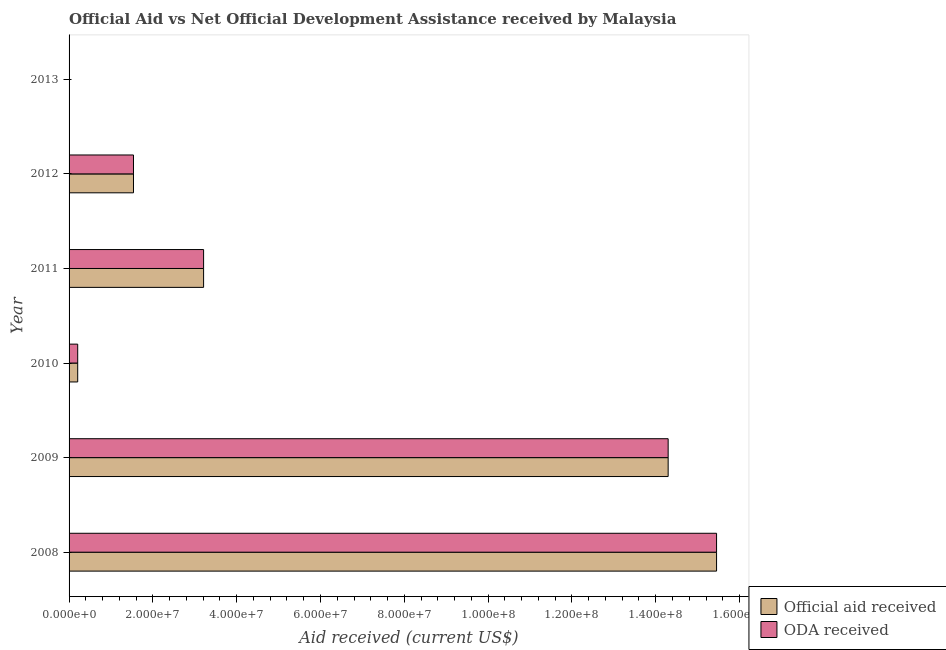Are the number of bars per tick equal to the number of legend labels?
Give a very brief answer. No. Are the number of bars on each tick of the Y-axis equal?
Give a very brief answer. No. How many bars are there on the 6th tick from the bottom?
Provide a short and direct response. 0. What is the label of the 6th group of bars from the top?
Keep it short and to the point. 2008. What is the official aid received in 2009?
Provide a short and direct response. 1.43e+08. Across all years, what is the maximum oda received?
Provide a short and direct response. 1.55e+08. What is the total oda received in the graph?
Keep it short and to the point. 3.47e+08. What is the difference between the oda received in 2008 and that in 2012?
Your answer should be very brief. 1.39e+08. What is the difference between the oda received in 2009 and the official aid received in 2011?
Your answer should be very brief. 1.11e+08. What is the average oda received per year?
Provide a short and direct response. 5.78e+07. In how many years, is the official aid received greater than 12000000 US$?
Give a very brief answer. 4. What is the ratio of the oda received in 2008 to that in 2012?
Give a very brief answer. 10.05. Is the official aid received in 2008 less than that in 2011?
Give a very brief answer. No. What is the difference between the highest and the second highest oda received?
Make the answer very short. 1.16e+07. What is the difference between the highest and the lowest official aid received?
Offer a terse response. 1.55e+08. Is the sum of the official aid received in 2011 and 2012 greater than the maximum oda received across all years?
Keep it short and to the point. No. How many bars are there?
Your response must be concise. 10. Does the graph contain grids?
Keep it short and to the point. No. How many legend labels are there?
Give a very brief answer. 2. What is the title of the graph?
Offer a very short reply. Official Aid vs Net Official Development Assistance received by Malaysia . Does "Urban" appear as one of the legend labels in the graph?
Offer a very short reply. No. What is the label or title of the X-axis?
Your answer should be compact. Aid received (current US$). What is the Aid received (current US$) of Official aid received in 2008?
Give a very brief answer. 1.55e+08. What is the Aid received (current US$) of ODA received in 2008?
Make the answer very short. 1.55e+08. What is the Aid received (current US$) of Official aid received in 2009?
Ensure brevity in your answer.  1.43e+08. What is the Aid received (current US$) of ODA received in 2009?
Your response must be concise. 1.43e+08. What is the Aid received (current US$) of Official aid received in 2010?
Your answer should be compact. 2.06e+06. What is the Aid received (current US$) of ODA received in 2010?
Offer a terse response. 2.06e+06. What is the Aid received (current US$) of Official aid received in 2011?
Offer a terse response. 3.21e+07. What is the Aid received (current US$) in ODA received in 2011?
Your answer should be compact. 3.21e+07. What is the Aid received (current US$) of Official aid received in 2012?
Your answer should be very brief. 1.54e+07. What is the Aid received (current US$) in ODA received in 2012?
Offer a terse response. 1.54e+07. Across all years, what is the maximum Aid received (current US$) in Official aid received?
Offer a terse response. 1.55e+08. Across all years, what is the maximum Aid received (current US$) in ODA received?
Offer a very short reply. 1.55e+08. Across all years, what is the minimum Aid received (current US$) in Official aid received?
Keep it short and to the point. 0. Across all years, what is the minimum Aid received (current US$) in ODA received?
Provide a succinct answer. 0. What is the total Aid received (current US$) in Official aid received in the graph?
Make the answer very short. 3.47e+08. What is the total Aid received (current US$) in ODA received in the graph?
Your answer should be compact. 3.47e+08. What is the difference between the Aid received (current US$) of Official aid received in 2008 and that in 2009?
Give a very brief answer. 1.16e+07. What is the difference between the Aid received (current US$) of ODA received in 2008 and that in 2009?
Your answer should be compact. 1.16e+07. What is the difference between the Aid received (current US$) in Official aid received in 2008 and that in 2010?
Give a very brief answer. 1.52e+08. What is the difference between the Aid received (current US$) of ODA received in 2008 and that in 2010?
Give a very brief answer. 1.52e+08. What is the difference between the Aid received (current US$) in Official aid received in 2008 and that in 2011?
Your response must be concise. 1.22e+08. What is the difference between the Aid received (current US$) in ODA received in 2008 and that in 2011?
Provide a succinct answer. 1.22e+08. What is the difference between the Aid received (current US$) of Official aid received in 2008 and that in 2012?
Ensure brevity in your answer.  1.39e+08. What is the difference between the Aid received (current US$) of ODA received in 2008 and that in 2012?
Offer a very short reply. 1.39e+08. What is the difference between the Aid received (current US$) in Official aid received in 2009 and that in 2010?
Your response must be concise. 1.41e+08. What is the difference between the Aid received (current US$) of ODA received in 2009 and that in 2010?
Provide a short and direct response. 1.41e+08. What is the difference between the Aid received (current US$) of Official aid received in 2009 and that in 2011?
Keep it short and to the point. 1.11e+08. What is the difference between the Aid received (current US$) in ODA received in 2009 and that in 2011?
Your answer should be very brief. 1.11e+08. What is the difference between the Aid received (current US$) of Official aid received in 2009 and that in 2012?
Provide a succinct answer. 1.28e+08. What is the difference between the Aid received (current US$) in ODA received in 2009 and that in 2012?
Offer a terse response. 1.28e+08. What is the difference between the Aid received (current US$) in Official aid received in 2010 and that in 2011?
Give a very brief answer. -3.00e+07. What is the difference between the Aid received (current US$) of ODA received in 2010 and that in 2011?
Provide a succinct answer. -3.00e+07. What is the difference between the Aid received (current US$) of Official aid received in 2010 and that in 2012?
Offer a terse response. -1.33e+07. What is the difference between the Aid received (current US$) in ODA received in 2010 and that in 2012?
Your response must be concise. -1.33e+07. What is the difference between the Aid received (current US$) of Official aid received in 2011 and that in 2012?
Your answer should be very brief. 1.67e+07. What is the difference between the Aid received (current US$) of ODA received in 2011 and that in 2012?
Give a very brief answer. 1.67e+07. What is the difference between the Aid received (current US$) in Official aid received in 2008 and the Aid received (current US$) in ODA received in 2009?
Offer a terse response. 1.16e+07. What is the difference between the Aid received (current US$) in Official aid received in 2008 and the Aid received (current US$) in ODA received in 2010?
Your answer should be very brief. 1.52e+08. What is the difference between the Aid received (current US$) of Official aid received in 2008 and the Aid received (current US$) of ODA received in 2011?
Provide a short and direct response. 1.22e+08. What is the difference between the Aid received (current US$) of Official aid received in 2008 and the Aid received (current US$) of ODA received in 2012?
Provide a succinct answer. 1.39e+08. What is the difference between the Aid received (current US$) of Official aid received in 2009 and the Aid received (current US$) of ODA received in 2010?
Make the answer very short. 1.41e+08. What is the difference between the Aid received (current US$) of Official aid received in 2009 and the Aid received (current US$) of ODA received in 2011?
Ensure brevity in your answer.  1.11e+08. What is the difference between the Aid received (current US$) of Official aid received in 2009 and the Aid received (current US$) of ODA received in 2012?
Provide a succinct answer. 1.28e+08. What is the difference between the Aid received (current US$) of Official aid received in 2010 and the Aid received (current US$) of ODA received in 2011?
Make the answer very short. -3.00e+07. What is the difference between the Aid received (current US$) in Official aid received in 2010 and the Aid received (current US$) in ODA received in 2012?
Make the answer very short. -1.33e+07. What is the difference between the Aid received (current US$) in Official aid received in 2011 and the Aid received (current US$) in ODA received in 2012?
Your answer should be very brief. 1.67e+07. What is the average Aid received (current US$) in Official aid received per year?
Keep it short and to the point. 5.78e+07. What is the average Aid received (current US$) in ODA received per year?
Make the answer very short. 5.78e+07. In the year 2008, what is the difference between the Aid received (current US$) in Official aid received and Aid received (current US$) in ODA received?
Offer a very short reply. 0. In the year 2009, what is the difference between the Aid received (current US$) of Official aid received and Aid received (current US$) of ODA received?
Give a very brief answer. 0. In the year 2010, what is the difference between the Aid received (current US$) in Official aid received and Aid received (current US$) in ODA received?
Your answer should be very brief. 0. In the year 2011, what is the difference between the Aid received (current US$) in Official aid received and Aid received (current US$) in ODA received?
Offer a terse response. 0. In the year 2012, what is the difference between the Aid received (current US$) in Official aid received and Aid received (current US$) in ODA received?
Your response must be concise. 0. What is the ratio of the Aid received (current US$) in Official aid received in 2008 to that in 2009?
Ensure brevity in your answer.  1.08. What is the ratio of the Aid received (current US$) in ODA received in 2008 to that in 2009?
Keep it short and to the point. 1.08. What is the ratio of the Aid received (current US$) in Official aid received in 2008 to that in 2010?
Keep it short and to the point. 75. What is the ratio of the Aid received (current US$) in ODA received in 2008 to that in 2010?
Keep it short and to the point. 75. What is the ratio of the Aid received (current US$) in Official aid received in 2008 to that in 2011?
Offer a terse response. 4.81. What is the ratio of the Aid received (current US$) of ODA received in 2008 to that in 2011?
Offer a very short reply. 4.81. What is the ratio of the Aid received (current US$) in Official aid received in 2008 to that in 2012?
Provide a short and direct response. 10.05. What is the ratio of the Aid received (current US$) in ODA received in 2008 to that in 2012?
Make the answer very short. 10.05. What is the ratio of the Aid received (current US$) of Official aid received in 2009 to that in 2010?
Your answer should be compact. 69.4. What is the ratio of the Aid received (current US$) of ODA received in 2009 to that in 2010?
Give a very brief answer. 69.4. What is the ratio of the Aid received (current US$) in Official aid received in 2009 to that in 2011?
Your response must be concise. 4.45. What is the ratio of the Aid received (current US$) of ODA received in 2009 to that in 2011?
Keep it short and to the point. 4.45. What is the ratio of the Aid received (current US$) of Official aid received in 2009 to that in 2012?
Your response must be concise. 9.3. What is the ratio of the Aid received (current US$) of ODA received in 2009 to that in 2012?
Give a very brief answer. 9.3. What is the ratio of the Aid received (current US$) in Official aid received in 2010 to that in 2011?
Offer a very short reply. 0.06. What is the ratio of the Aid received (current US$) of ODA received in 2010 to that in 2011?
Ensure brevity in your answer.  0.06. What is the ratio of the Aid received (current US$) of Official aid received in 2010 to that in 2012?
Your answer should be compact. 0.13. What is the ratio of the Aid received (current US$) in ODA received in 2010 to that in 2012?
Offer a terse response. 0.13. What is the ratio of the Aid received (current US$) in Official aid received in 2011 to that in 2012?
Provide a short and direct response. 2.09. What is the ratio of the Aid received (current US$) of ODA received in 2011 to that in 2012?
Provide a succinct answer. 2.09. What is the difference between the highest and the second highest Aid received (current US$) in Official aid received?
Your answer should be compact. 1.16e+07. What is the difference between the highest and the second highest Aid received (current US$) in ODA received?
Your response must be concise. 1.16e+07. What is the difference between the highest and the lowest Aid received (current US$) in Official aid received?
Offer a terse response. 1.55e+08. What is the difference between the highest and the lowest Aid received (current US$) of ODA received?
Keep it short and to the point. 1.55e+08. 